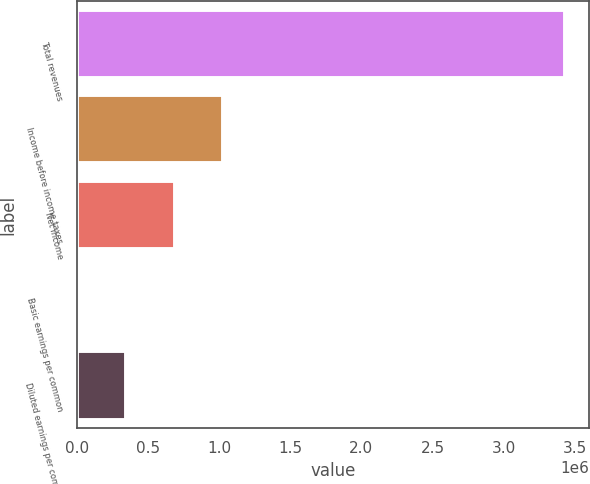Convert chart. <chart><loc_0><loc_0><loc_500><loc_500><bar_chart><fcel>Total revenues<fcel>Income before income taxes<fcel>Net income<fcel>Basic earnings per common<fcel>Diluted earnings per common<nl><fcel>3.43148e+06<fcel>1.02944e+06<fcel>686296<fcel>0.5<fcel>343148<nl></chart> 